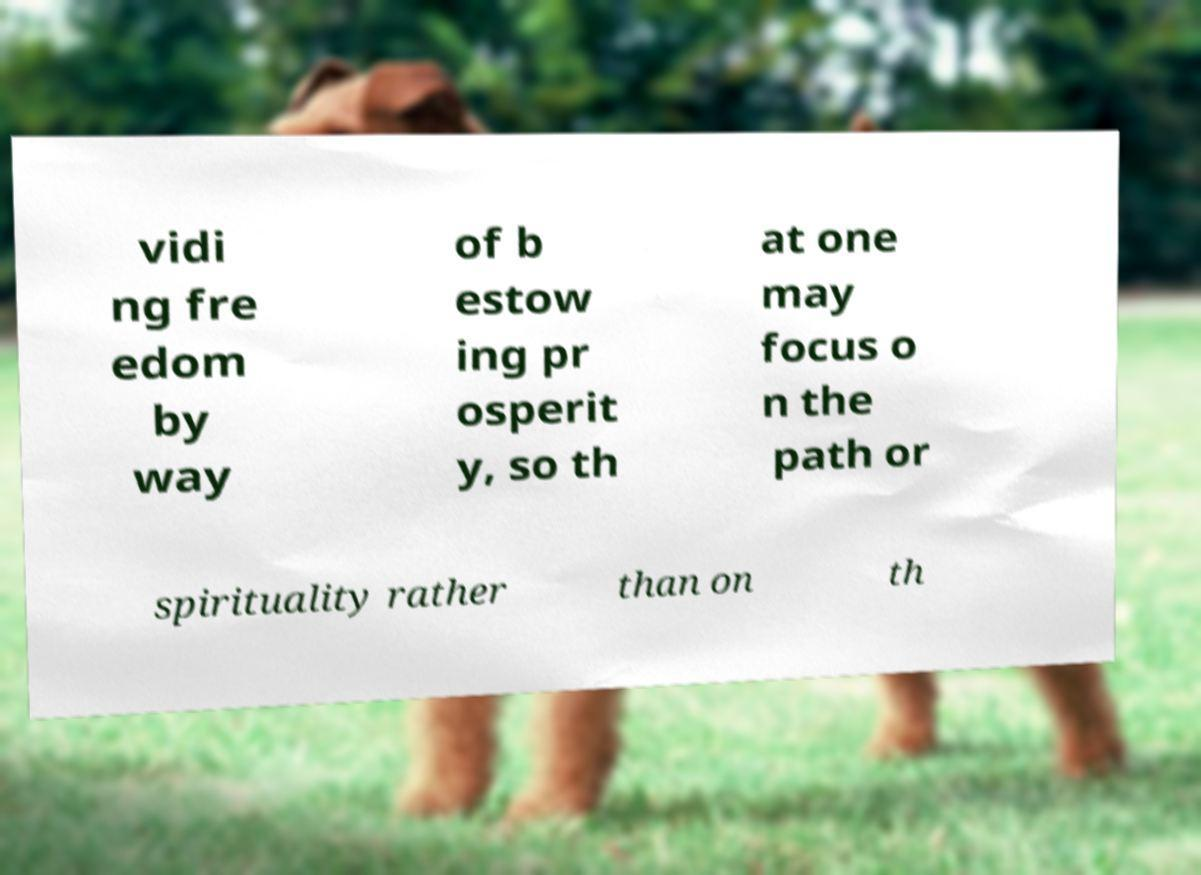Can you read and provide the text displayed in the image?This photo seems to have some interesting text. Can you extract and type it out for me? vidi ng fre edom by way of b estow ing pr osperit y, so th at one may focus o n the path or spirituality rather than on th 